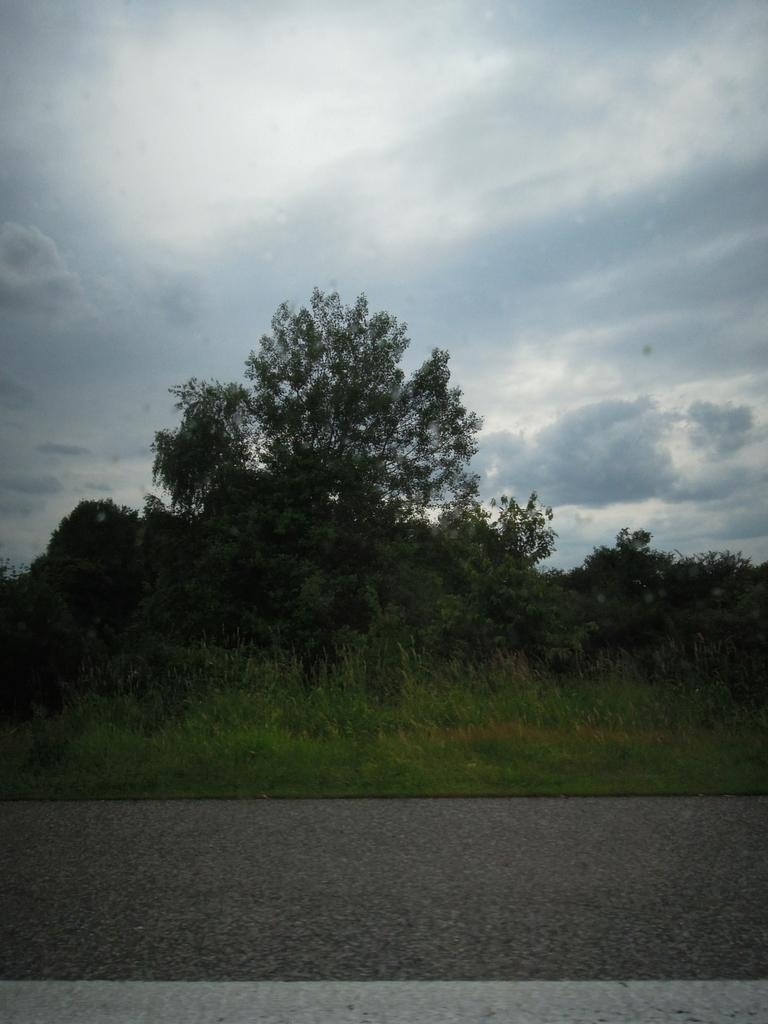What is the main feature of the image? There is a road in the image. What can be seen near the road? There are plants and trees near the road. What is visible in the background of the image? The sky is visible in the background of the image. What can be observed in the sky? Clouds are present in the sky. What type of channel can be seen running alongside the road in the image? There is no channel present alongside the road in the image. 